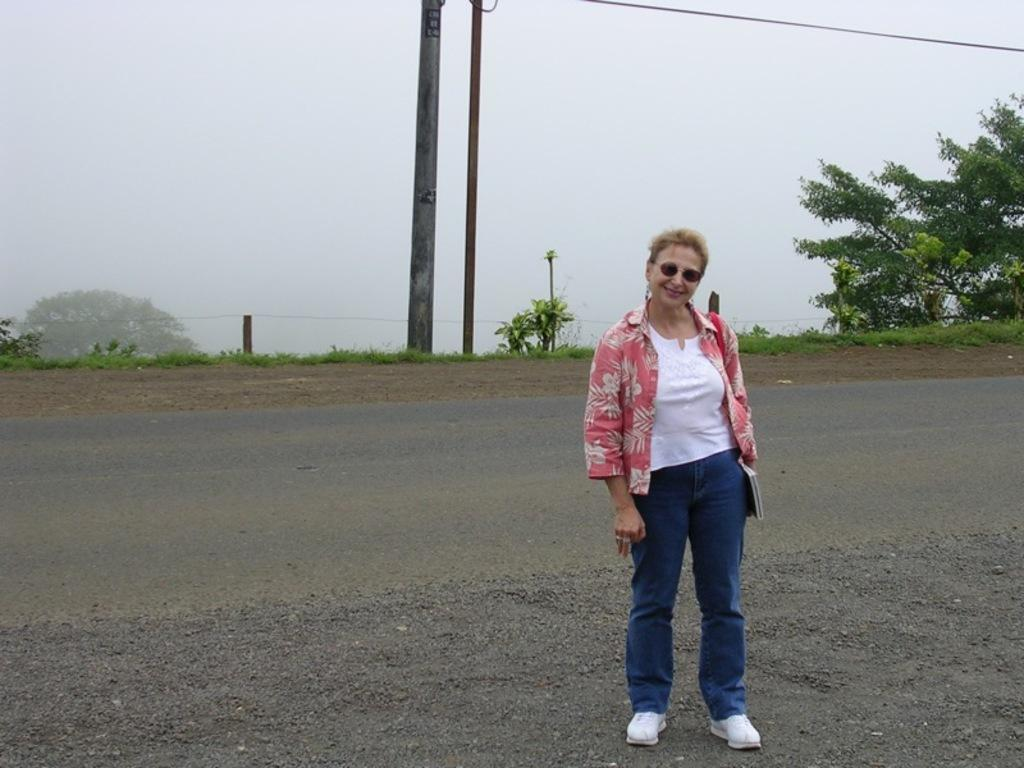What is the woman doing in the image? The woman is standing on the ground in the image. What objects can be seen in the image besides the woman? There are poles, a wire, plants, and trees in the image. What is visible in the background of the image? The sky is visible in the image. What type of pencil is the woman holding in the image? There is no pencil present in the image. Is there a stage visible in the image? No, there is no stage present in the image. 